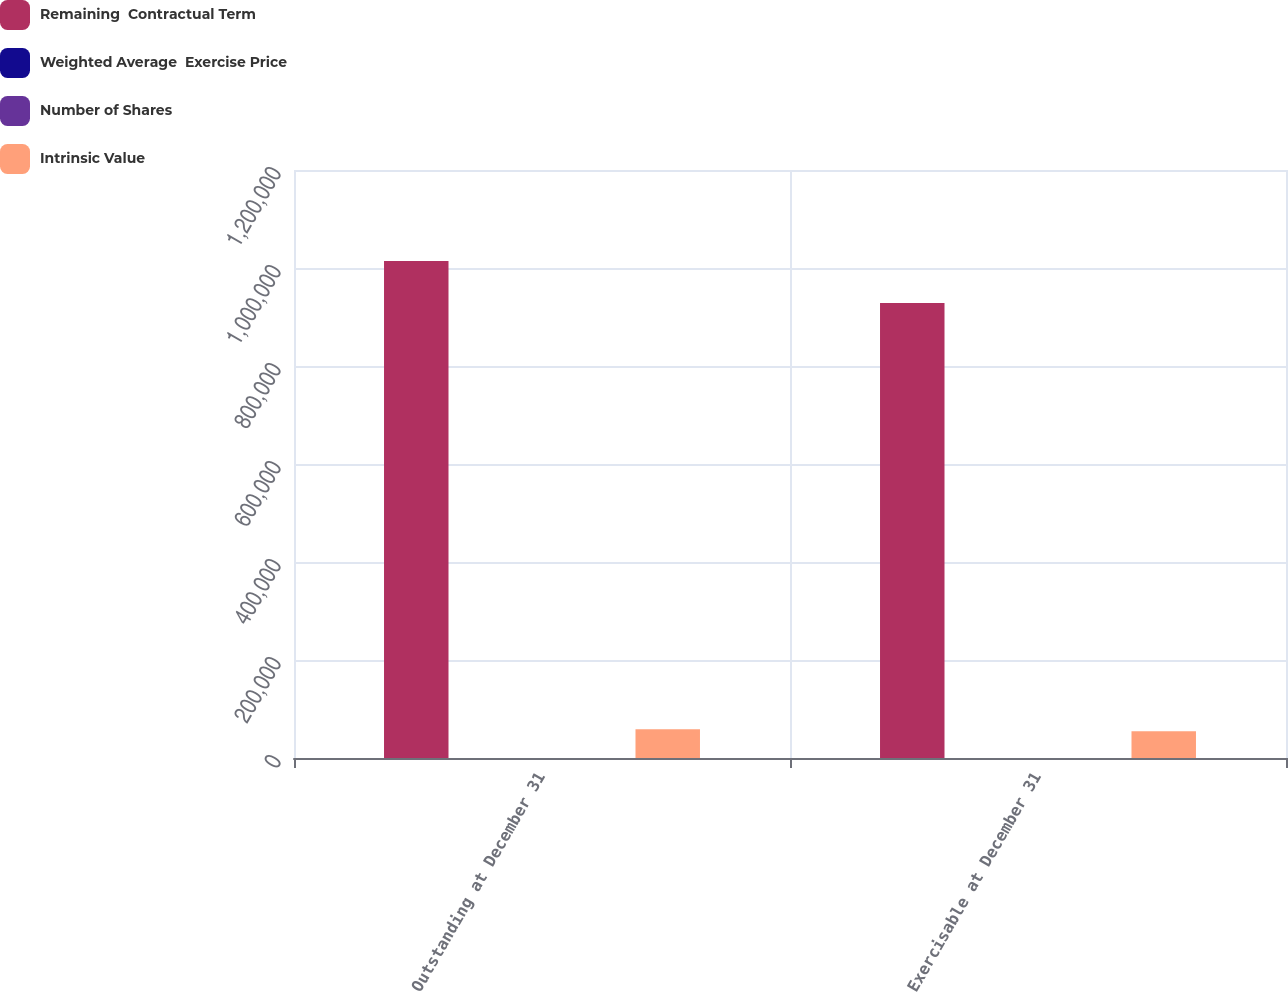Convert chart. <chart><loc_0><loc_0><loc_500><loc_500><stacked_bar_chart><ecel><fcel>Outstanding at December 31<fcel>Exercisable at December 31<nl><fcel>Remaining  Contractual Term<fcel>1.01442e+06<fcel>928813<nl><fcel>Weighted Average  Exercise Price<fcel>13.81<fcel>13.05<nl><fcel>Number of Shares<fcel>3.1<fcel>2.9<nl><fcel>Intrinsic Value<fcel>58731<fcel>54482<nl></chart> 